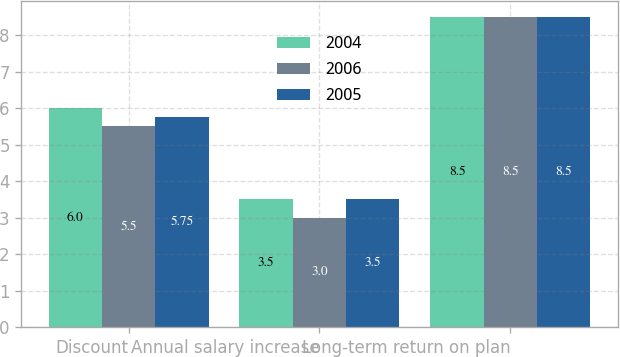Convert chart to OTSL. <chart><loc_0><loc_0><loc_500><loc_500><stacked_bar_chart><ecel><fcel>Discount<fcel>Annual salary increase<fcel>Long-term return on plan<nl><fcel>2004<fcel>6<fcel>3.5<fcel>8.5<nl><fcel>2006<fcel>5.5<fcel>3<fcel>8.5<nl><fcel>2005<fcel>5.75<fcel>3.5<fcel>8.5<nl></chart> 